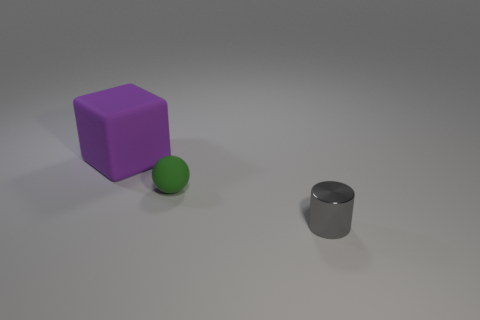Add 2 tiny green spheres. How many objects exist? 5 Subtract all cubes. How many objects are left? 2 Subtract 0 blue cylinders. How many objects are left? 3 Subtract all blue balls. Subtract all blue cubes. How many balls are left? 1 Subtract all green objects. Subtract all large matte cubes. How many objects are left? 1 Add 3 large purple objects. How many large purple objects are left? 4 Add 2 big matte objects. How many big matte objects exist? 3 